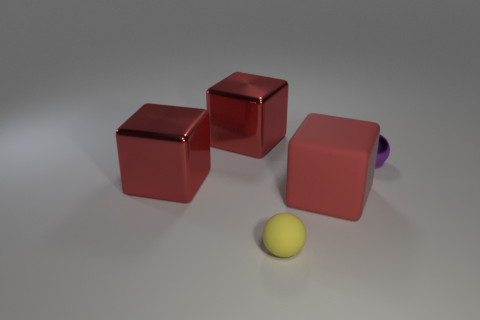Add 2 purple spheres. How many objects exist? 7 Subtract all spheres. How many objects are left? 3 Subtract 0 green blocks. How many objects are left? 5 Subtract all big red metal objects. Subtract all big red rubber cubes. How many objects are left? 2 Add 5 big red matte things. How many big red matte things are left? 6 Add 5 large red blocks. How many large red blocks exist? 8 